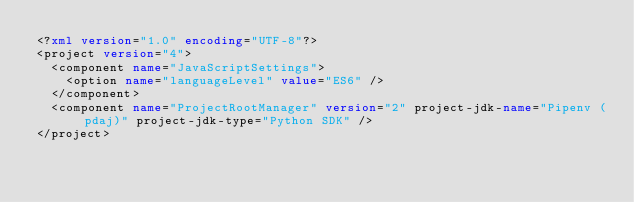Convert code to text. <code><loc_0><loc_0><loc_500><loc_500><_XML_><?xml version="1.0" encoding="UTF-8"?>
<project version="4">
  <component name="JavaScriptSettings">
    <option name="languageLevel" value="ES6" />
  </component>
  <component name="ProjectRootManager" version="2" project-jdk-name="Pipenv (pdaj)" project-jdk-type="Python SDK" />
</project></code> 